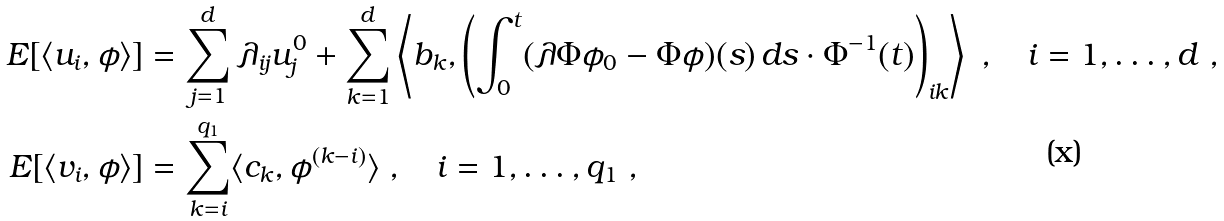Convert formula to latex. <formula><loc_0><loc_0><loc_500><loc_500>E [ \langle u _ { i } , \phi \rangle ] & = \sum _ { j = 1 } ^ { d } \lambda _ { i j } u ^ { 0 } _ { j } + \sum _ { k = 1 } ^ { d } \left \langle b _ { k } , \left ( \int _ { 0 } ^ { t } ( \lambda \Phi \phi _ { 0 } - \Phi \phi ) ( s ) \, d s \cdot \Phi ^ { - 1 } ( t ) \right ) _ { i k } \right \rangle \ , \quad i = 1 , \dots , d \ , \\ E [ \langle v _ { i } , \phi \rangle ] & = \sum _ { k = i } ^ { q _ { 1 } } \langle c _ { k } , \phi ^ { ( k - i ) } \rangle \ , \quad i = 1 , \dots , q _ { 1 } \ ,</formula> 